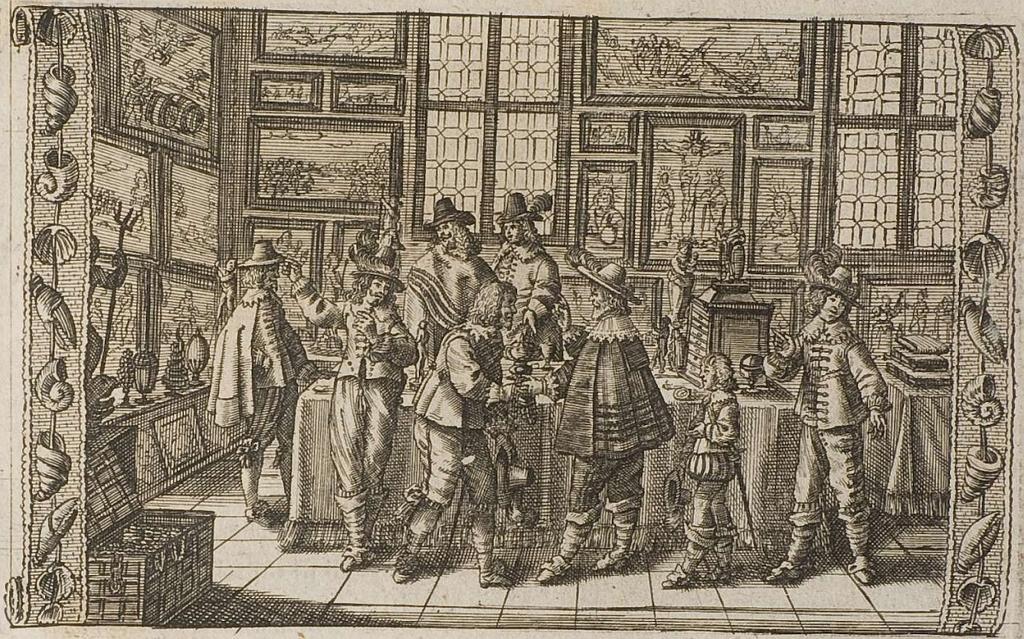Could you give a brief overview of what you see in this image? This picture consists of an art , in the art I can see person images and the wall and window and photo frames and box and table visible. 